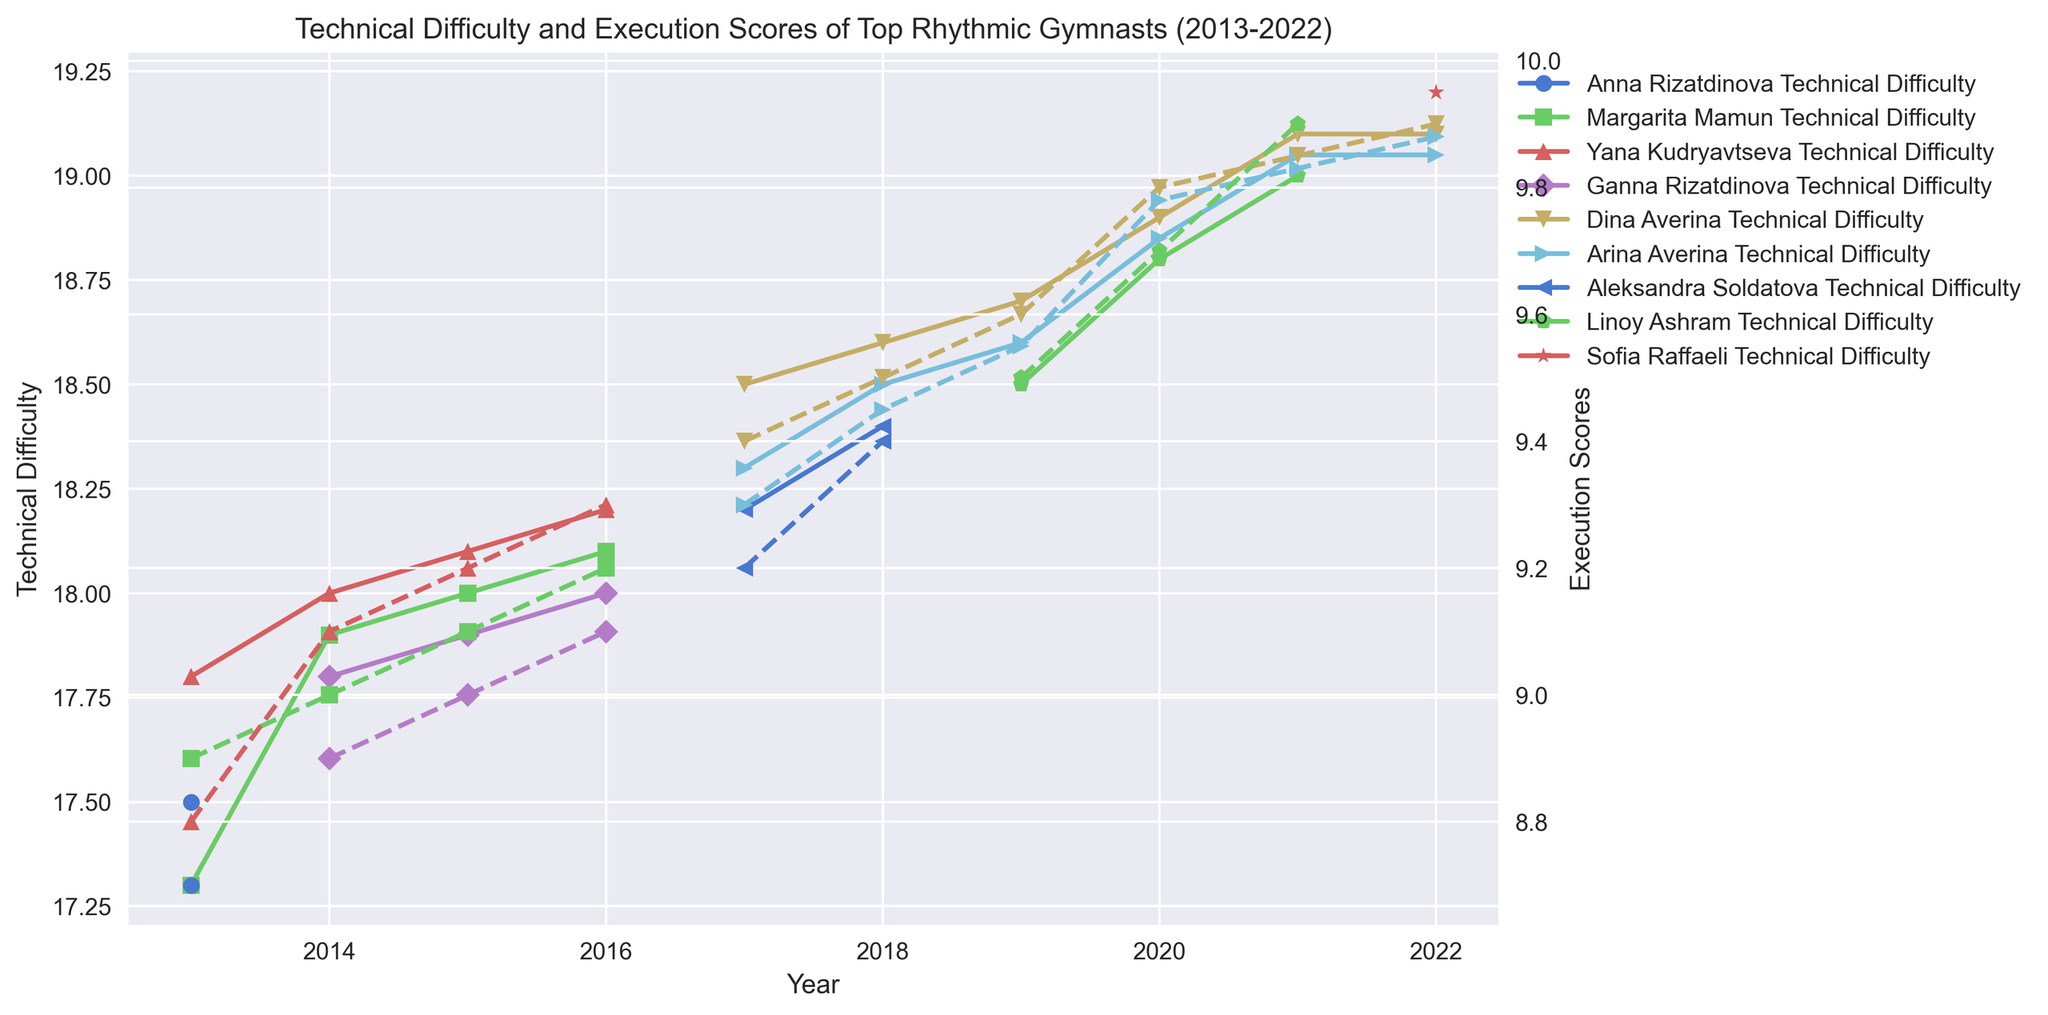Which gymnast had the highest Technical Difficulty score in 2022? To find the gymnast with the highest Technical Difficulty score in 2022, look at the Technical Difficulty scores for each gymnast in that year. Sofia Raffaeli had a score of 19.200, which is the highest.
Answer: Sofia Raffaeli How did Arina Averina's Execution Scores change from 2020 to 2022? Check Arina Averina's Execution Scores for the years 2020 and 2022. In 2020, her Execution Score was 9.780, and in 2022, it was 9.880. The score increased by 0.100 points.
Answer: Increased by 0.100 Who had a higher Execution Score in 2017, Dina Averina or Aleksandra Soldatova? Compare the Execution Scores of Dina Averina and Aleksandra Soldatova in 2017. Dina Averina had a score of 9.400, while Aleksandra Soldatova had a score of 9.200. Dina Averina had the higher score.
Answer: Dina Averina What is the average Technical Difficulty score for Linoy Ashram from 2019 to 2021? Calculate the average of Linoy Ashram's Technical Difficulty scores for 2019, 2020, and 2021. The scores are 18.500, 18.800, and 19.000 respectively. The average is (18.500 + 18.800 + 19.000) / 3 = 18.767.
Answer: 18.767 Did Yana Kudryavtseva or Margarita Mamun show greater improvement in Execution Scores from 2013 to 2016? Check the Execution Scores for 2013 and 2016 for both gymnasts. Yana Kudryavtseva improved from 8.800 to 9.300 (an increase of 0.500 points). Margarita Mamun improved from 8.900 to 9.200 (an increase of 0.300 points). Yana Kudryavtseva showed greater improvement.
Answer: Yana Kudryavtseva Which gymnast had the highest combined (sum of) Technical Difficulty and Execution Scores in 2021? Calculate the sum of Technical Difficulty and Execution Scores for each gymnast in 2021. Linoy Ashram: 19.000 + 9.900 = 28.900, Dina Averina: 19.100 + 9.850 = 28.950, Arina Averina: 19.050 + 9.830 = 28.880. Dina Averina had the highest combined score of 28.950.
Answer: Dina Averina Who had a higher Technical Difficulty score in 2018, Dina Averina or Arina Averina? Compare the Technical Difficulty scores of Dina Averina and Arina Averina in 2018. Dina Averina had a score of 18.600, while Arina Averina had a score of 18.500. Dina Averina had the higher score.
Answer: Dina Averina How many gymnasts had an Execution Score of 9.800 or more in 2020? Check the Execution Scores for all gymnasts in 2020. Dina Averina had 9.800, and Arina Averina had 9.780. No other gymnast had an Execution Score of 9.800 or more. So, only one gymnast had a score of 9.800 or more.
Answer: One Which year's average Technical Difficulty score was higher, 2017 or 2021? Calculate the average Technical Difficulty score for the gymnasts in 2017 and 2021. For 2017: (18.500 + 18.300 + 18.200) / 3 = 18.333. For 2021: (19.000 + 19.100 + 19.050) / 3 = 19.050. The average Technical Difficulty score was higher in 2021.
Answer: 2021 